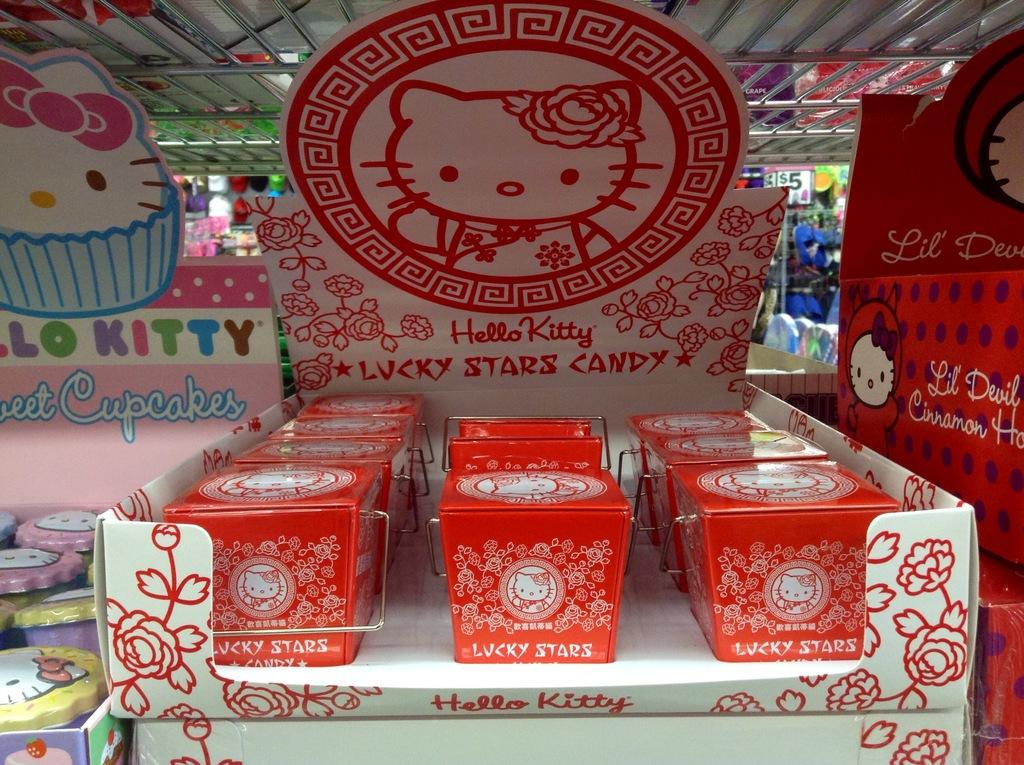<image>
Create a compact narrative representing the image presented. Red boxes of Hello Kitty Lucky Stars Candy are on display. 